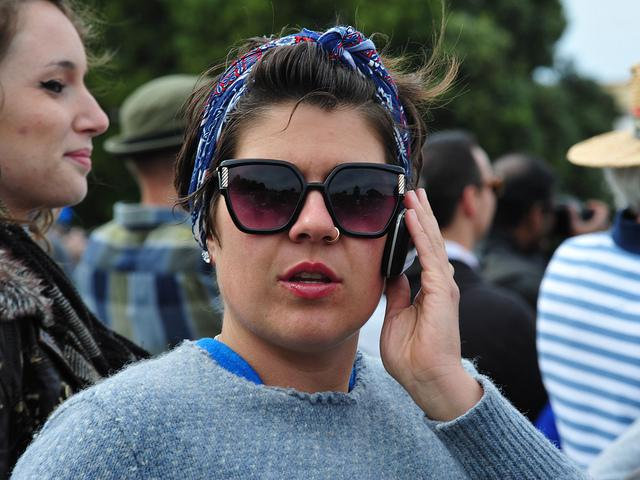What is the most likely purpose for the glasses on the girls face? sun protection 